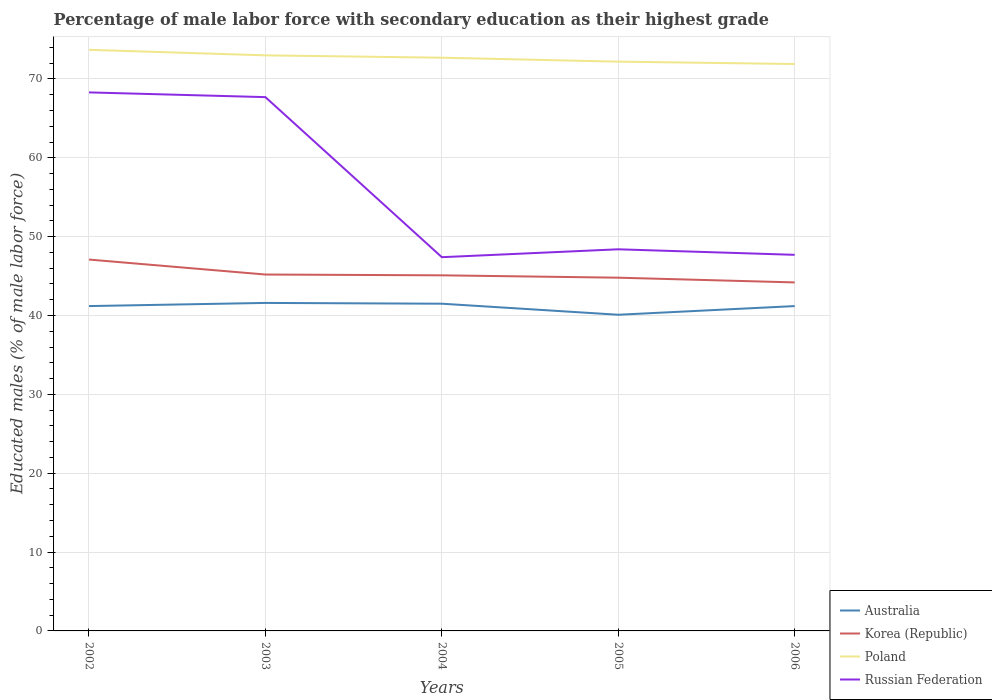Is the number of lines equal to the number of legend labels?
Keep it short and to the point. Yes. Across all years, what is the maximum percentage of male labor force with secondary education in Korea (Republic)?
Offer a very short reply. 44.2. In which year was the percentage of male labor force with secondary education in Russian Federation maximum?
Your answer should be compact. 2004. What is the total percentage of male labor force with secondary education in Poland in the graph?
Provide a succinct answer. 0.3. What is the difference between the highest and the second highest percentage of male labor force with secondary education in Korea (Republic)?
Offer a terse response. 2.9. Is the percentage of male labor force with secondary education in Russian Federation strictly greater than the percentage of male labor force with secondary education in Australia over the years?
Your response must be concise. No. How many lines are there?
Keep it short and to the point. 4. What is the difference between two consecutive major ticks on the Y-axis?
Provide a succinct answer. 10. Does the graph contain any zero values?
Provide a succinct answer. No. Does the graph contain grids?
Keep it short and to the point. Yes. Where does the legend appear in the graph?
Your response must be concise. Bottom right. What is the title of the graph?
Provide a short and direct response. Percentage of male labor force with secondary education as their highest grade. Does "Jordan" appear as one of the legend labels in the graph?
Ensure brevity in your answer.  No. What is the label or title of the X-axis?
Offer a terse response. Years. What is the label or title of the Y-axis?
Provide a succinct answer. Educated males (% of male labor force). What is the Educated males (% of male labor force) in Australia in 2002?
Provide a succinct answer. 41.2. What is the Educated males (% of male labor force) in Korea (Republic) in 2002?
Offer a terse response. 47.1. What is the Educated males (% of male labor force) in Poland in 2002?
Provide a succinct answer. 73.7. What is the Educated males (% of male labor force) of Russian Federation in 2002?
Your answer should be very brief. 68.3. What is the Educated males (% of male labor force) of Australia in 2003?
Your response must be concise. 41.6. What is the Educated males (% of male labor force) of Korea (Republic) in 2003?
Offer a very short reply. 45.2. What is the Educated males (% of male labor force) in Poland in 2003?
Give a very brief answer. 73. What is the Educated males (% of male labor force) of Russian Federation in 2003?
Give a very brief answer. 67.7. What is the Educated males (% of male labor force) in Australia in 2004?
Your answer should be compact. 41.5. What is the Educated males (% of male labor force) of Korea (Republic) in 2004?
Ensure brevity in your answer.  45.1. What is the Educated males (% of male labor force) in Poland in 2004?
Offer a terse response. 72.7. What is the Educated males (% of male labor force) of Russian Federation in 2004?
Your answer should be very brief. 47.4. What is the Educated males (% of male labor force) in Australia in 2005?
Provide a succinct answer. 40.1. What is the Educated males (% of male labor force) of Korea (Republic) in 2005?
Make the answer very short. 44.8. What is the Educated males (% of male labor force) in Poland in 2005?
Give a very brief answer. 72.2. What is the Educated males (% of male labor force) in Russian Federation in 2005?
Offer a very short reply. 48.4. What is the Educated males (% of male labor force) of Australia in 2006?
Give a very brief answer. 41.2. What is the Educated males (% of male labor force) of Korea (Republic) in 2006?
Ensure brevity in your answer.  44.2. What is the Educated males (% of male labor force) of Poland in 2006?
Make the answer very short. 71.9. What is the Educated males (% of male labor force) in Russian Federation in 2006?
Keep it short and to the point. 47.7. Across all years, what is the maximum Educated males (% of male labor force) of Australia?
Keep it short and to the point. 41.6. Across all years, what is the maximum Educated males (% of male labor force) of Korea (Republic)?
Your response must be concise. 47.1. Across all years, what is the maximum Educated males (% of male labor force) in Poland?
Make the answer very short. 73.7. Across all years, what is the maximum Educated males (% of male labor force) of Russian Federation?
Give a very brief answer. 68.3. Across all years, what is the minimum Educated males (% of male labor force) in Australia?
Your response must be concise. 40.1. Across all years, what is the minimum Educated males (% of male labor force) of Korea (Republic)?
Offer a terse response. 44.2. Across all years, what is the minimum Educated males (% of male labor force) of Poland?
Keep it short and to the point. 71.9. Across all years, what is the minimum Educated males (% of male labor force) in Russian Federation?
Your answer should be compact. 47.4. What is the total Educated males (% of male labor force) of Australia in the graph?
Keep it short and to the point. 205.6. What is the total Educated males (% of male labor force) of Korea (Republic) in the graph?
Offer a terse response. 226.4. What is the total Educated males (% of male labor force) of Poland in the graph?
Offer a terse response. 363.5. What is the total Educated males (% of male labor force) in Russian Federation in the graph?
Make the answer very short. 279.5. What is the difference between the Educated males (% of male labor force) in Australia in 2002 and that in 2003?
Your answer should be compact. -0.4. What is the difference between the Educated males (% of male labor force) in Korea (Republic) in 2002 and that in 2003?
Make the answer very short. 1.9. What is the difference between the Educated males (% of male labor force) in Poland in 2002 and that in 2003?
Your answer should be very brief. 0.7. What is the difference between the Educated males (% of male labor force) in Russian Federation in 2002 and that in 2003?
Make the answer very short. 0.6. What is the difference between the Educated males (% of male labor force) in Australia in 2002 and that in 2004?
Provide a short and direct response. -0.3. What is the difference between the Educated males (% of male labor force) in Korea (Republic) in 2002 and that in 2004?
Make the answer very short. 2. What is the difference between the Educated males (% of male labor force) in Poland in 2002 and that in 2004?
Provide a succinct answer. 1. What is the difference between the Educated males (% of male labor force) in Russian Federation in 2002 and that in 2004?
Give a very brief answer. 20.9. What is the difference between the Educated males (% of male labor force) in Australia in 2002 and that in 2005?
Keep it short and to the point. 1.1. What is the difference between the Educated males (% of male labor force) of Korea (Republic) in 2002 and that in 2005?
Keep it short and to the point. 2.3. What is the difference between the Educated males (% of male labor force) of Australia in 2002 and that in 2006?
Make the answer very short. 0. What is the difference between the Educated males (% of male labor force) of Poland in 2002 and that in 2006?
Your response must be concise. 1.8. What is the difference between the Educated males (% of male labor force) of Russian Federation in 2002 and that in 2006?
Your response must be concise. 20.6. What is the difference between the Educated males (% of male labor force) of Australia in 2003 and that in 2004?
Offer a very short reply. 0.1. What is the difference between the Educated males (% of male labor force) in Korea (Republic) in 2003 and that in 2004?
Provide a succinct answer. 0.1. What is the difference between the Educated males (% of male labor force) of Poland in 2003 and that in 2004?
Offer a terse response. 0.3. What is the difference between the Educated males (% of male labor force) of Russian Federation in 2003 and that in 2004?
Ensure brevity in your answer.  20.3. What is the difference between the Educated males (% of male labor force) of Poland in 2003 and that in 2005?
Offer a terse response. 0.8. What is the difference between the Educated males (% of male labor force) of Russian Federation in 2003 and that in 2005?
Your response must be concise. 19.3. What is the difference between the Educated males (% of male labor force) of Poland in 2003 and that in 2006?
Provide a short and direct response. 1.1. What is the difference between the Educated males (% of male labor force) in Australia in 2004 and that in 2005?
Provide a short and direct response. 1.4. What is the difference between the Educated males (% of male labor force) of Korea (Republic) in 2004 and that in 2005?
Offer a very short reply. 0.3. What is the difference between the Educated males (% of male labor force) of Poland in 2004 and that in 2005?
Your answer should be very brief. 0.5. What is the difference between the Educated males (% of male labor force) of Russian Federation in 2004 and that in 2005?
Ensure brevity in your answer.  -1. What is the difference between the Educated males (% of male labor force) in Korea (Republic) in 2004 and that in 2006?
Offer a terse response. 0.9. What is the difference between the Educated males (% of male labor force) of Australia in 2002 and the Educated males (% of male labor force) of Korea (Republic) in 2003?
Your answer should be very brief. -4. What is the difference between the Educated males (% of male labor force) of Australia in 2002 and the Educated males (% of male labor force) of Poland in 2003?
Offer a very short reply. -31.8. What is the difference between the Educated males (% of male labor force) in Australia in 2002 and the Educated males (% of male labor force) in Russian Federation in 2003?
Provide a succinct answer. -26.5. What is the difference between the Educated males (% of male labor force) of Korea (Republic) in 2002 and the Educated males (% of male labor force) of Poland in 2003?
Make the answer very short. -25.9. What is the difference between the Educated males (% of male labor force) of Korea (Republic) in 2002 and the Educated males (% of male labor force) of Russian Federation in 2003?
Ensure brevity in your answer.  -20.6. What is the difference between the Educated males (% of male labor force) in Australia in 2002 and the Educated males (% of male labor force) in Korea (Republic) in 2004?
Your answer should be compact. -3.9. What is the difference between the Educated males (% of male labor force) of Australia in 2002 and the Educated males (% of male labor force) of Poland in 2004?
Your answer should be compact. -31.5. What is the difference between the Educated males (% of male labor force) of Australia in 2002 and the Educated males (% of male labor force) of Russian Federation in 2004?
Offer a very short reply. -6.2. What is the difference between the Educated males (% of male labor force) in Korea (Republic) in 2002 and the Educated males (% of male labor force) in Poland in 2004?
Provide a short and direct response. -25.6. What is the difference between the Educated males (% of male labor force) in Poland in 2002 and the Educated males (% of male labor force) in Russian Federation in 2004?
Offer a very short reply. 26.3. What is the difference between the Educated males (% of male labor force) in Australia in 2002 and the Educated males (% of male labor force) in Poland in 2005?
Make the answer very short. -31. What is the difference between the Educated males (% of male labor force) of Australia in 2002 and the Educated males (% of male labor force) of Russian Federation in 2005?
Make the answer very short. -7.2. What is the difference between the Educated males (% of male labor force) of Korea (Republic) in 2002 and the Educated males (% of male labor force) of Poland in 2005?
Provide a succinct answer. -25.1. What is the difference between the Educated males (% of male labor force) in Poland in 2002 and the Educated males (% of male labor force) in Russian Federation in 2005?
Ensure brevity in your answer.  25.3. What is the difference between the Educated males (% of male labor force) of Australia in 2002 and the Educated males (% of male labor force) of Korea (Republic) in 2006?
Provide a succinct answer. -3. What is the difference between the Educated males (% of male labor force) of Australia in 2002 and the Educated males (% of male labor force) of Poland in 2006?
Offer a terse response. -30.7. What is the difference between the Educated males (% of male labor force) of Korea (Republic) in 2002 and the Educated males (% of male labor force) of Poland in 2006?
Your answer should be very brief. -24.8. What is the difference between the Educated males (% of male labor force) of Korea (Republic) in 2002 and the Educated males (% of male labor force) of Russian Federation in 2006?
Provide a short and direct response. -0.6. What is the difference between the Educated males (% of male labor force) in Australia in 2003 and the Educated males (% of male labor force) in Poland in 2004?
Give a very brief answer. -31.1. What is the difference between the Educated males (% of male labor force) of Australia in 2003 and the Educated males (% of male labor force) of Russian Federation in 2004?
Provide a succinct answer. -5.8. What is the difference between the Educated males (% of male labor force) in Korea (Republic) in 2003 and the Educated males (% of male labor force) in Poland in 2004?
Your answer should be very brief. -27.5. What is the difference between the Educated males (% of male labor force) in Korea (Republic) in 2003 and the Educated males (% of male labor force) in Russian Federation in 2004?
Offer a very short reply. -2.2. What is the difference between the Educated males (% of male labor force) in Poland in 2003 and the Educated males (% of male labor force) in Russian Federation in 2004?
Offer a terse response. 25.6. What is the difference between the Educated males (% of male labor force) of Australia in 2003 and the Educated males (% of male labor force) of Poland in 2005?
Provide a succinct answer. -30.6. What is the difference between the Educated males (% of male labor force) in Australia in 2003 and the Educated males (% of male labor force) in Russian Federation in 2005?
Your response must be concise. -6.8. What is the difference between the Educated males (% of male labor force) of Korea (Republic) in 2003 and the Educated males (% of male labor force) of Poland in 2005?
Your answer should be very brief. -27. What is the difference between the Educated males (% of male labor force) of Korea (Republic) in 2003 and the Educated males (% of male labor force) of Russian Federation in 2005?
Your answer should be very brief. -3.2. What is the difference between the Educated males (% of male labor force) of Poland in 2003 and the Educated males (% of male labor force) of Russian Federation in 2005?
Your answer should be very brief. 24.6. What is the difference between the Educated males (% of male labor force) of Australia in 2003 and the Educated males (% of male labor force) of Korea (Republic) in 2006?
Offer a very short reply. -2.6. What is the difference between the Educated males (% of male labor force) in Australia in 2003 and the Educated males (% of male labor force) in Poland in 2006?
Give a very brief answer. -30.3. What is the difference between the Educated males (% of male labor force) of Korea (Republic) in 2003 and the Educated males (% of male labor force) of Poland in 2006?
Your answer should be very brief. -26.7. What is the difference between the Educated males (% of male labor force) in Poland in 2003 and the Educated males (% of male labor force) in Russian Federation in 2006?
Provide a short and direct response. 25.3. What is the difference between the Educated males (% of male labor force) of Australia in 2004 and the Educated males (% of male labor force) of Korea (Republic) in 2005?
Your answer should be compact. -3.3. What is the difference between the Educated males (% of male labor force) of Australia in 2004 and the Educated males (% of male labor force) of Poland in 2005?
Your answer should be compact. -30.7. What is the difference between the Educated males (% of male labor force) of Korea (Republic) in 2004 and the Educated males (% of male labor force) of Poland in 2005?
Ensure brevity in your answer.  -27.1. What is the difference between the Educated males (% of male labor force) of Poland in 2004 and the Educated males (% of male labor force) of Russian Federation in 2005?
Make the answer very short. 24.3. What is the difference between the Educated males (% of male labor force) of Australia in 2004 and the Educated males (% of male labor force) of Korea (Republic) in 2006?
Provide a short and direct response. -2.7. What is the difference between the Educated males (% of male labor force) in Australia in 2004 and the Educated males (% of male labor force) in Poland in 2006?
Your answer should be compact. -30.4. What is the difference between the Educated males (% of male labor force) in Australia in 2004 and the Educated males (% of male labor force) in Russian Federation in 2006?
Offer a very short reply. -6.2. What is the difference between the Educated males (% of male labor force) of Korea (Republic) in 2004 and the Educated males (% of male labor force) of Poland in 2006?
Give a very brief answer. -26.8. What is the difference between the Educated males (% of male labor force) of Poland in 2004 and the Educated males (% of male labor force) of Russian Federation in 2006?
Your answer should be compact. 25. What is the difference between the Educated males (% of male labor force) in Australia in 2005 and the Educated males (% of male labor force) in Korea (Republic) in 2006?
Make the answer very short. -4.1. What is the difference between the Educated males (% of male labor force) in Australia in 2005 and the Educated males (% of male labor force) in Poland in 2006?
Your answer should be compact. -31.8. What is the difference between the Educated males (% of male labor force) in Korea (Republic) in 2005 and the Educated males (% of male labor force) in Poland in 2006?
Offer a terse response. -27.1. What is the average Educated males (% of male labor force) of Australia per year?
Provide a succinct answer. 41.12. What is the average Educated males (% of male labor force) in Korea (Republic) per year?
Provide a succinct answer. 45.28. What is the average Educated males (% of male labor force) of Poland per year?
Your answer should be very brief. 72.7. What is the average Educated males (% of male labor force) in Russian Federation per year?
Give a very brief answer. 55.9. In the year 2002, what is the difference between the Educated males (% of male labor force) of Australia and Educated males (% of male labor force) of Korea (Republic)?
Offer a very short reply. -5.9. In the year 2002, what is the difference between the Educated males (% of male labor force) of Australia and Educated males (% of male labor force) of Poland?
Offer a terse response. -32.5. In the year 2002, what is the difference between the Educated males (% of male labor force) in Australia and Educated males (% of male labor force) in Russian Federation?
Your response must be concise. -27.1. In the year 2002, what is the difference between the Educated males (% of male labor force) of Korea (Republic) and Educated males (% of male labor force) of Poland?
Your answer should be very brief. -26.6. In the year 2002, what is the difference between the Educated males (% of male labor force) in Korea (Republic) and Educated males (% of male labor force) in Russian Federation?
Keep it short and to the point. -21.2. In the year 2003, what is the difference between the Educated males (% of male labor force) of Australia and Educated males (% of male labor force) of Poland?
Your answer should be compact. -31.4. In the year 2003, what is the difference between the Educated males (% of male labor force) of Australia and Educated males (% of male labor force) of Russian Federation?
Provide a succinct answer. -26.1. In the year 2003, what is the difference between the Educated males (% of male labor force) of Korea (Republic) and Educated males (% of male labor force) of Poland?
Offer a very short reply. -27.8. In the year 2003, what is the difference between the Educated males (% of male labor force) of Korea (Republic) and Educated males (% of male labor force) of Russian Federation?
Provide a short and direct response. -22.5. In the year 2004, what is the difference between the Educated males (% of male labor force) in Australia and Educated males (% of male labor force) in Korea (Republic)?
Give a very brief answer. -3.6. In the year 2004, what is the difference between the Educated males (% of male labor force) in Australia and Educated males (% of male labor force) in Poland?
Give a very brief answer. -31.2. In the year 2004, what is the difference between the Educated males (% of male labor force) in Korea (Republic) and Educated males (% of male labor force) in Poland?
Offer a very short reply. -27.6. In the year 2004, what is the difference between the Educated males (% of male labor force) in Poland and Educated males (% of male labor force) in Russian Federation?
Offer a very short reply. 25.3. In the year 2005, what is the difference between the Educated males (% of male labor force) in Australia and Educated males (% of male labor force) in Poland?
Provide a succinct answer. -32.1. In the year 2005, what is the difference between the Educated males (% of male labor force) in Australia and Educated males (% of male labor force) in Russian Federation?
Your answer should be very brief. -8.3. In the year 2005, what is the difference between the Educated males (% of male labor force) in Korea (Republic) and Educated males (% of male labor force) in Poland?
Provide a short and direct response. -27.4. In the year 2005, what is the difference between the Educated males (% of male labor force) of Korea (Republic) and Educated males (% of male labor force) of Russian Federation?
Offer a terse response. -3.6. In the year 2005, what is the difference between the Educated males (% of male labor force) in Poland and Educated males (% of male labor force) in Russian Federation?
Provide a short and direct response. 23.8. In the year 2006, what is the difference between the Educated males (% of male labor force) in Australia and Educated males (% of male labor force) in Poland?
Offer a very short reply. -30.7. In the year 2006, what is the difference between the Educated males (% of male labor force) in Australia and Educated males (% of male labor force) in Russian Federation?
Your answer should be very brief. -6.5. In the year 2006, what is the difference between the Educated males (% of male labor force) in Korea (Republic) and Educated males (% of male labor force) in Poland?
Your answer should be compact. -27.7. In the year 2006, what is the difference between the Educated males (% of male labor force) in Korea (Republic) and Educated males (% of male labor force) in Russian Federation?
Give a very brief answer. -3.5. In the year 2006, what is the difference between the Educated males (% of male labor force) of Poland and Educated males (% of male labor force) of Russian Federation?
Keep it short and to the point. 24.2. What is the ratio of the Educated males (% of male labor force) in Korea (Republic) in 2002 to that in 2003?
Your answer should be compact. 1.04. What is the ratio of the Educated males (% of male labor force) in Poland in 2002 to that in 2003?
Offer a terse response. 1.01. What is the ratio of the Educated males (% of male labor force) of Russian Federation in 2002 to that in 2003?
Provide a succinct answer. 1.01. What is the ratio of the Educated males (% of male labor force) of Korea (Republic) in 2002 to that in 2004?
Give a very brief answer. 1.04. What is the ratio of the Educated males (% of male labor force) of Poland in 2002 to that in 2004?
Your answer should be compact. 1.01. What is the ratio of the Educated males (% of male labor force) of Russian Federation in 2002 to that in 2004?
Your answer should be very brief. 1.44. What is the ratio of the Educated males (% of male labor force) of Australia in 2002 to that in 2005?
Offer a very short reply. 1.03. What is the ratio of the Educated males (% of male labor force) in Korea (Republic) in 2002 to that in 2005?
Your answer should be compact. 1.05. What is the ratio of the Educated males (% of male labor force) in Poland in 2002 to that in 2005?
Keep it short and to the point. 1.02. What is the ratio of the Educated males (% of male labor force) in Russian Federation in 2002 to that in 2005?
Your response must be concise. 1.41. What is the ratio of the Educated males (% of male labor force) in Australia in 2002 to that in 2006?
Your response must be concise. 1. What is the ratio of the Educated males (% of male labor force) in Korea (Republic) in 2002 to that in 2006?
Your answer should be very brief. 1.07. What is the ratio of the Educated males (% of male labor force) in Russian Federation in 2002 to that in 2006?
Your response must be concise. 1.43. What is the ratio of the Educated males (% of male labor force) of Australia in 2003 to that in 2004?
Make the answer very short. 1. What is the ratio of the Educated males (% of male labor force) of Korea (Republic) in 2003 to that in 2004?
Offer a terse response. 1. What is the ratio of the Educated males (% of male labor force) in Russian Federation in 2003 to that in 2004?
Give a very brief answer. 1.43. What is the ratio of the Educated males (% of male labor force) in Australia in 2003 to that in 2005?
Make the answer very short. 1.04. What is the ratio of the Educated males (% of male labor force) of Korea (Republic) in 2003 to that in 2005?
Provide a succinct answer. 1.01. What is the ratio of the Educated males (% of male labor force) in Poland in 2003 to that in 2005?
Offer a terse response. 1.01. What is the ratio of the Educated males (% of male labor force) in Russian Federation in 2003 to that in 2005?
Ensure brevity in your answer.  1.4. What is the ratio of the Educated males (% of male labor force) of Australia in 2003 to that in 2006?
Give a very brief answer. 1.01. What is the ratio of the Educated males (% of male labor force) in Korea (Republic) in 2003 to that in 2006?
Offer a terse response. 1.02. What is the ratio of the Educated males (% of male labor force) of Poland in 2003 to that in 2006?
Provide a succinct answer. 1.02. What is the ratio of the Educated males (% of male labor force) of Russian Federation in 2003 to that in 2006?
Ensure brevity in your answer.  1.42. What is the ratio of the Educated males (% of male labor force) of Australia in 2004 to that in 2005?
Offer a terse response. 1.03. What is the ratio of the Educated males (% of male labor force) in Poland in 2004 to that in 2005?
Provide a short and direct response. 1.01. What is the ratio of the Educated males (% of male labor force) of Russian Federation in 2004 to that in 2005?
Provide a succinct answer. 0.98. What is the ratio of the Educated males (% of male labor force) in Australia in 2004 to that in 2006?
Provide a short and direct response. 1.01. What is the ratio of the Educated males (% of male labor force) in Korea (Republic) in 2004 to that in 2006?
Provide a short and direct response. 1.02. What is the ratio of the Educated males (% of male labor force) of Poland in 2004 to that in 2006?
Your answer should be very brief. 1.01. What is the ratio of the Educated males (% of male labor force) of Australia in 2005 to that in 2006?
Keep it short and to the point. 0.97. What is the ratio of the Educated males (% of male labor force) in Korea (Republic) in 2005 to that in 2006?
Ensure brevity in your answer.  1.01. What is the ratio of the Educated males (% of male labor force) in Poland in 2005 to that in 2006?
Provide a succinct answer. 1. What is the ratio of the Educated males (% of male labor force) in Russian Federation in 2005 to that in 2006?
Give a very brief answer. 1.01. What is the difference between the highest and the second highest Educated males (% of male labor force) of Poland?
Offer a terse response. 0.7. What is the difference between the highest and the second highest Educated males (% of male labor force) of Russian Federation?
Give a very brief answer. 0.6. What is the difference between the highest and the lowest Educated males (% of male labor force) in Australia?
Ensure brevity in your answer.  1.5. What is the difference between the highest and the lowest Educated males (% of male labor force) in Poland?
Your answer should be very brief. 1.8. What is the difference between the highest and the lowest Educated males (% of male labor force) of Russian Federation?
Ensure brevity in your answer.  20.9. 